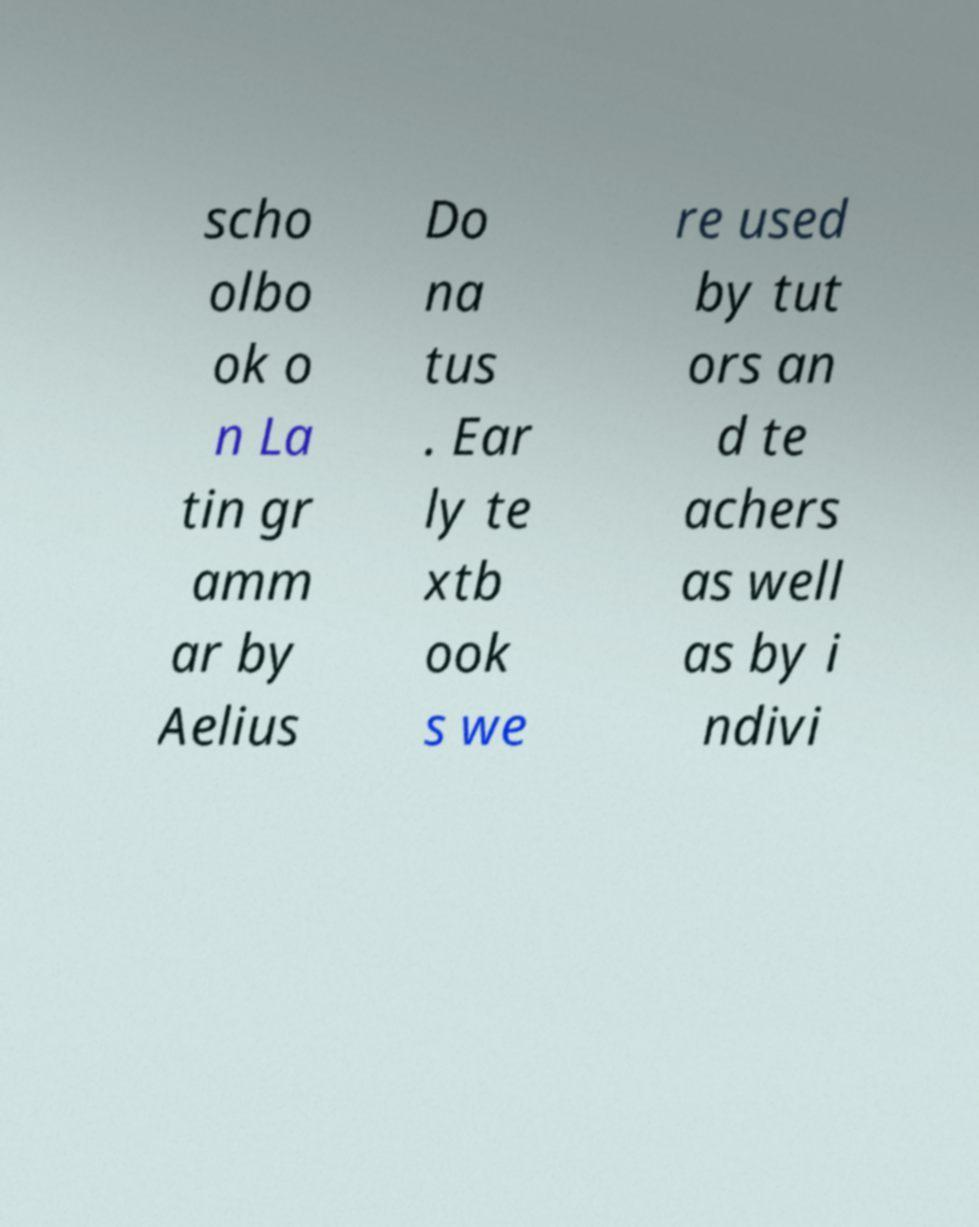What messages or text are displayed in this image? I need them in a readable, typed format. scho olbo ok o n La tin gr amm ar by Aelius Do na tus . Ear ly te xtb ook s we re used by tut ors an d te achers as well as by i ndivi 